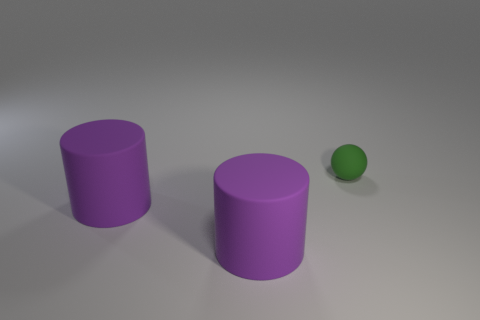Subtract 1 spheres. How many spheres are left? 0 Add 1 cyan blocks. How many objects exist? 4 Subtract all cylinders. How many objects are left? 1 Subtract 0 gray cylinders. How many objects are left? 3 Subtract all blue balls. Subtract all green cylinders. How many balls are left? 1 Subtract all purple cubes. How many blue cylinders are left? 0 Subtract all large purple cylinders. Subtract all spheres. How many objects are left? 0 Add 3 purple matte objects. How many purple matte objects are left? 5 Add 3 small green shiny cubes. How many small green shiny cubes exist? 3 